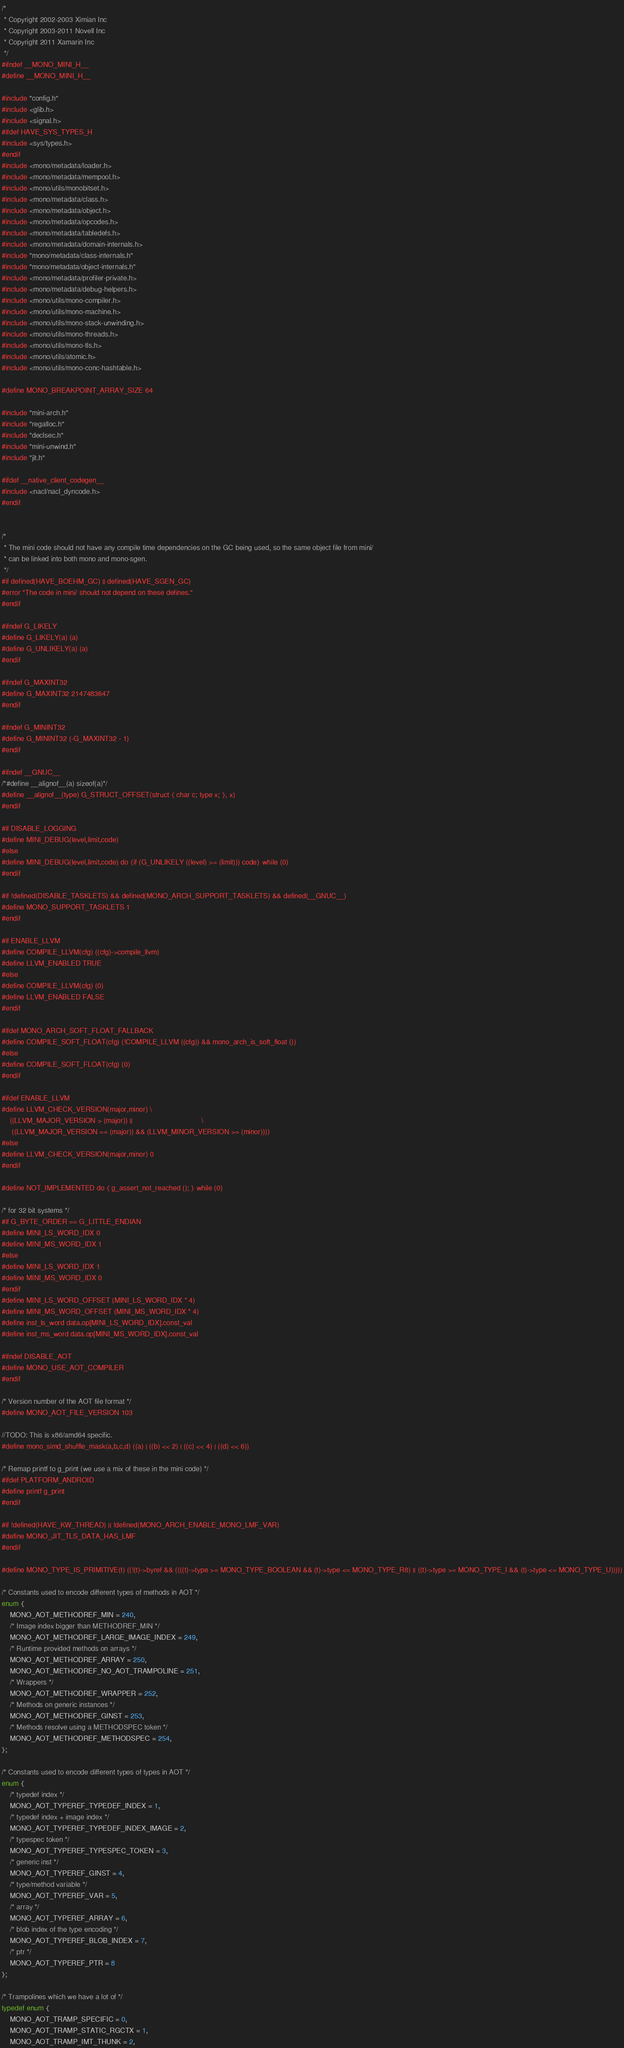<code> <loc_0><loc_0><loc_500><loc_500><_C_>/*
 * Copyright 2002-2003 Ximian Inc
 * Copyright 2003-2011 Novell Inc
 * Copyright 2011 Xamarin Inc
 */
#ifndef __MONO_MINI_H__
#define __MONO_MINI_H__

#include "config.h"
#include <glib.h>
#include <signal.h>
#ifdef HAVE_SYS_TYPES_H
#include <sys/types.h>
#endif
#include <mono/metadata/loader.h>
#include <mono/metadata/mempool.h>
#include <mono/utils/monobitset.h>
#include <mono/metadata/class.h>
#include <mono/metadata/object.h>
#include <mono/metadata/opcodes.h>
#include <mono/metadata/tabledefs.h>
#include <mono/metadata/domain-internals.h>
#include "mono/metadata/class-internals.h"
#include "mono/metadata/object-internals.h"
#include <mono/metadata/profiler-private.h>
#include <mono/metadata/debug-helpers.h>
#include <mono/utils/mono-compiler.h>
#include <mono/utils/mono-machine.h>
#include <mono/utils/mono-stack-unwinding.h>
#include <mono/utils/mono-threads.h>
#include <mono/utils/mono-tls.h>
#include <mono/utils/atomic.h>
#include <mono/utils/mono-conc-hashtable.h>

#define MONO_BREAKPOINT_ARRAY_SIZE 64

#include "mini-arch.h"
#include "regalloc.h"
#include "declsec.h"
#include "mini-unwind.h"
#include "jit.h"

#ifdef __native_client_codegen__
#include <nacl/nacl_dyncode.h>
#endif


/*
 * The mini code should not have any compile time dependencies on the GC being used, so the same object file from mini/
 * can be linked into both mono and mono-sgen.
 */
#if defined(HAVE_BOEHM_GC) || defined(HAVE_SGEN_GC)
#error "The code in mini/ should not depend on these defines."
#endif

#ifndef G_LIKELY
#define G_LIKELY(a) (a)
#define G_UNLIKELY(a) (a)
#endif

#ifndef G_MAXINT32
#define G_MAXINT32 2147483647
#endif

#ifndef G_MININT32
#define G_MININT32 (-G_MAXINT32 - 1)
#endif

#ifndef __GNUC__
/*#define __alignof__(a) sizeof(a)*/
#define __alignof__(type) G_STRUCT_OFFSET(struct { char c; type x; }, x)
#endif

#if DISABLE_LOGGING
#define MINI_DEBUG(level,limit,code)
#else
#define MINI_DEBUG(level,limit,code) do {if (G_UNLIKELY ((level) >= (limit))) code} while (0)
#endif

#if !defined(DISABLE_TASKLETS) && defined(MONO_ARCH_SUPPORT_TASKLETS) && defined(__GNUC__)
#define MONO_SUPPORT_TASKLETS 1
#endif

#if ENABLE_LLVM
#define COMPILE_LLVM(cfg) ((cfg)->compile_llvm)
#define LLVM_ENABLED TRUE
#else
#define COMPILE_LLVM(cfg) (0)
#define LLVM_ENABLED FALSE
#endif

#ifdef MONO_ARCH_SOFT_FLOAT_FALLBACK
#define COMPILE_SOFT_FLOAT(cfg) (!COMPILE_LLVM ((cfg)) && mono_arch_is_soft_float ())
#else
#define COMPILE_SOFT_FLOAT(cfg) (0)
#endif

#ifdef ENABLE_LLVM
#define LLVM_CHECK_VERSION(major,minor) \
	((LLVM_MAJOR_VERSION > (major)) ||									\
	 ((LLVM_MAJOR_VERSION == (major)) && (LLVM_MINOR_VERSION >= (minor))))
#else
#define LLVM_CHECK_VERSION(major,minor) 0
#endif

#define NOT_IMPLEMENTED do { g_assert_not_reached (); } while (0)

/* for 32 bit systems */
#if G_BYTE_ORDER == G_LITTLE_ENDIAN
#define MINI_LS_WORD_IDX 0
#define MINI_MS_WORD_IDX 1
#else
#define MINI_LS_WORD_IDX 1
#define MINI_MS_WORD_IDX 0
#endif
#define MINI_LS_WORD_OFFSET (MINI_LS_WORD_IDX * 4)
#define MINI_MS_WORD_OFFSET (MINI_MS_WORD_IDX * 4)
#define inst_ls_word data.op[MINI_LS_WORD_IDX].const_val
#define inst_ms_word data.op[MINI_MS_WORD_IDX].const_val

#ifndef DISABLE_AOT
#define MONO_USE_AOT_COMPILER
#endif

/* Version number of the AOT file format */
#define MONO_AOT_FILE_VERSION 103

//TODO: This is x86/amd64 specific.
#define mono_simd_shuffle_mask(a,b,c,d) ((a) | ((b) << 2) | ((c) << 4) | ((d) << 6))

/* Remap printf to g_print (we use a mix of these in the mini code) */
#ifdef PLATFORM_ANDROID
#define printf g_print
#endif

#if !defined(HAVE_KW_THREAD) || !defined(MONO_ARCH_ENABLE_MONO_LMF_VAR)
#define MONO_JIT_TLS_DATA_HAS_LMF
#endif

#define MONO_TYPE_IS_PRIMITIVE(t) ((!(t)->byref && ((((t)->type >= MONO_TYPE_BOOLEAN && (t)->type <= MONO_TYPE_R8) || ((t)->type >= MONO_TYPE_I && (t)->type <= MONO_TYPE_U)))))

/* Constants used to encode different types of methods in AOT */
enum {
	MONO_AOT_METHODREF_MIN = 240,
	/* Image index bigger than METHODREF_MIN */
	MONO_AOT_METHODREF_LARGE_IMAGE_INDEX = 249,
	/* Runtime provided methods on arrays */
	MONO_AOT_METHODREF_ARRAY = 250,
	MONO_AOT_METHODREF_NO_AOT_TRAMPOLINE = 251,
	/* Wrappers */
	MONO_AOT_METHODREF_WRAPPER = 252,
	/* Methods on generic instances */
	MONO_AOT_METHODREF_GINST = 253,
	/* Methods resolve using a METHODSPEC token */
	MONO_AOT_METHODREF_METHODSPEC = 254,
};

/* Constants used to encode different types of types in AOT */
enum {
	/* typedef index */
	MONO_AOT_TYPEREF_TYPEDEF_INDEX = 1,
	/* typedef index + image index */
	MONO_AOT_TYPEREF_TYPEDEF_INDEX_IMAGE = 2,
	/* typespec token */
	MONO_AOT_TYPEREF_TYPESPEC_TOKEN = 3,
	/* generic inst */
	MONO_AOT_TYPEREF_GINST = 4,
	/* type/method variable */
	MONO_AOT_TYPEREF_VAR = 5,
	/* array */
	MONO_AOT_TYPEREF_ARRAY = 6,
	/* blob index of the type encoding */
	MONO_AOT_TYPEREF_BLOB_INDEX = 7,
	/* ptr */
	MONO_AOT_TYPEREF_PTR = 8
};

/* Trampolines which we have a lot of */
typedef enum {
	MONO_AOT_TRAMP_SPECIFIC = 0,
	MONO_AOT_TRAMP_STATIC_RGCTX = 1,
	MONO_AOT_TRAMP_IMT_THUNK = 2,</code> 